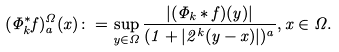Convert formula to latex. <formula><loc_0><loc_0><loc_500><loc_500>( \Phi _ { k } ^ { * } f ) ^ { \Omega } _ { a } ( x ) \colon = \sup _ { y \in \Omega } \frac { | ( \Phi _ { k } \ast f ) ( y ) | } { ( 1 + | 2 ^ { k } ( y - x ) | ) ^ { a } } , x \in \Omega .</formula> 